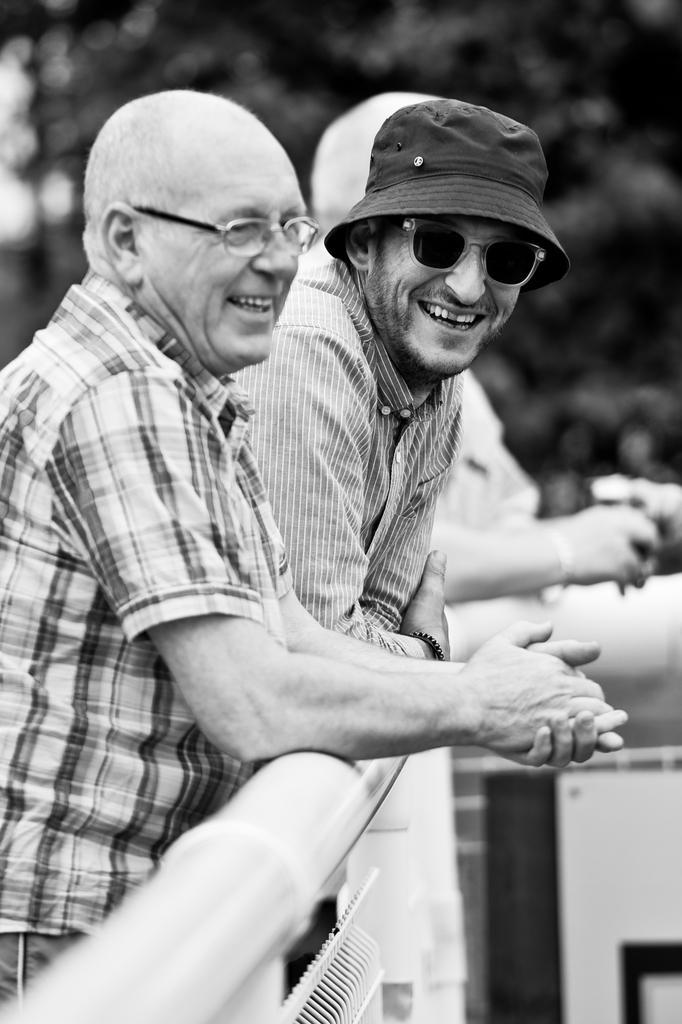Please provide a concise description of this image. Here in this picture we can see a group of men standing over a place by keeping their hands on the railing present in front of them over there and they are smiling and one of them is wearing spectacles and another person is wearing goggles and hat on him over there. 